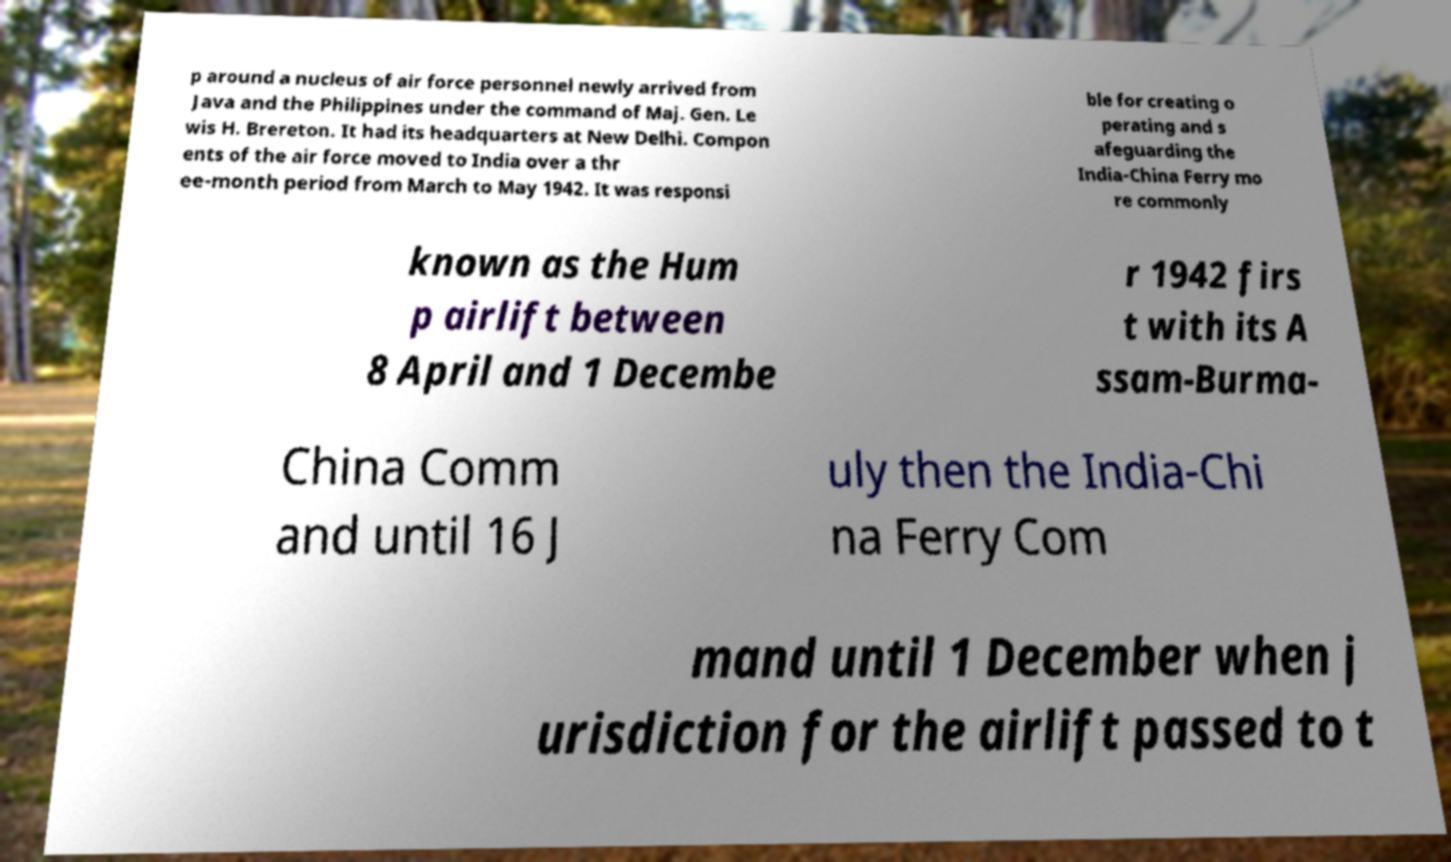Could you assist in decoding the text presented in this image and type it out clearly? p around a nucleus of air force personnel newly arrived from Java and the Philippines under the command of Maj. Gen. Le wis H. Brereton. It had its headquarters at New Delhi. Compon ents of the air force moved to India over a thr ee-month period from March to May 1942. It was responsi ble for creating o perating and s afeguarding the India-China Ferry mo re commonly known as the Hum p airlift between 8 April and 1 Decembe r 1942 firs t with its A ssam-Burma- China Comm and until 16 J uly then the India-Chi na Ferry Com mand until 1 December when j urisdiction for the airlift passed to t 